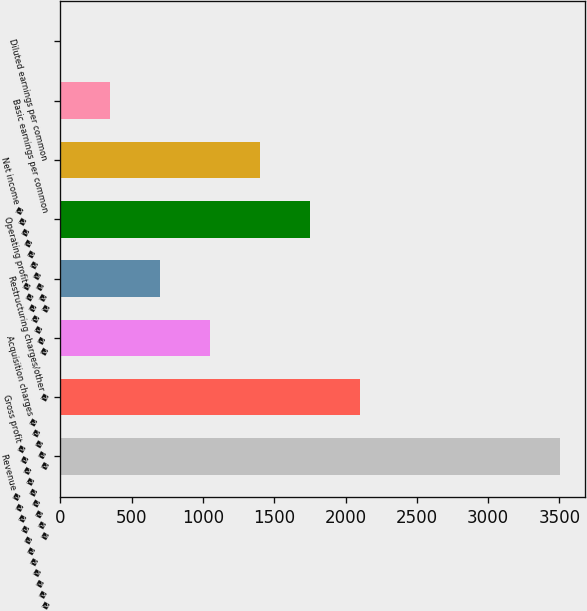Convert chart to OTSL. <chart><loc_0><loc_0><loc_500><loc_500><bar_chart><fcel>Revenue � � � � � � � � � � �<fcel>Gross profit � � � � � � � � �<fcel>Acquisition charges � � � � �<fcel>Restructuring charges/other �<fcel>Operating profit� � � � � � �<fcel>Net income � � � � � � � � � �<fcel>Basic earnings per common<fcel>Diluted earnings per common<nl><fcel>3501<fcel>2100.88<fcel>1050.82<fcel>700.8<fcel>1750.86<fcel>1400.84<fcel>350.78<fcel>0.76<nl></chart> 